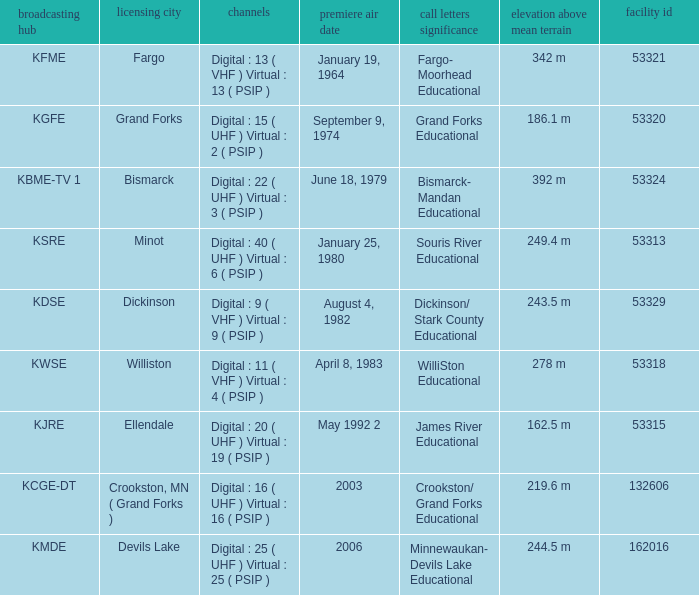What is the haat of devils lake 244.5 m. 